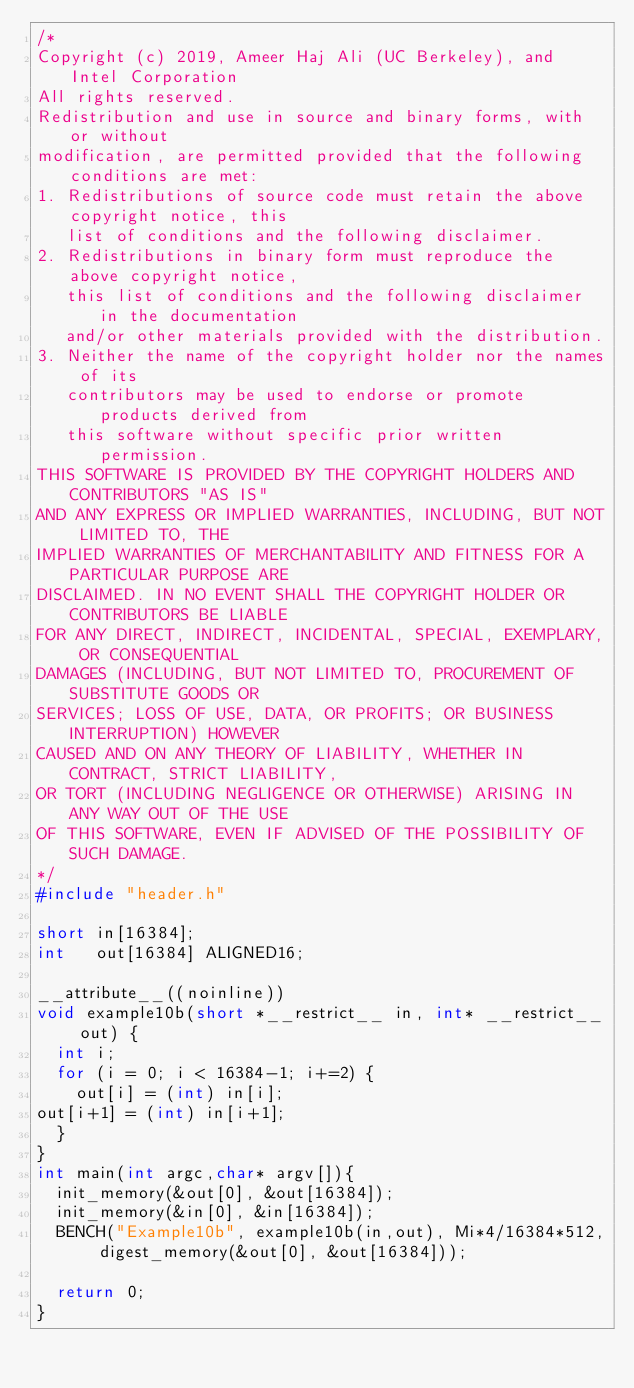Convert code to text. <code><loc_0><loc_0><loc_500><loc_500><_C_>/*
Copyright (c) 2019, Ameer Haj Ali (UC Berkeley), and Intel Corporation
All rights reserved.
Redistribution and use in source and binary forms, with or without
modification, are permitted provided that the following conditions are met:
1. Redistributions of source code must retain the above copyright notice, this
   list of conditions and the following disclaimer.
2. Redistributions in binary form must reproduce the above copyright notice,
   this list of conditions and the following disclaimer in the documentation
   and/or other materials provided with the distribution.
3. Neither the name of the copyright holder nor the names of its
   contributors may be used to endorse or promote products derived from
   this software without specific prior written permission.
THIS SOFTWARE IS PROVIDED BY THE COPYRIGHT HOLDERS AND CONTRIBUTORS "AS IS"
AND ANY EXPRESS OR IMPLIED WARRANTIES, INCLUDING, BUT NOT LIMITED TO, THE
IMPLIED WARRANTIES OF MERCHANTABILITY AND FITNESS FOR A PARTICULAR PURPOSE ARE
DISCLAIMED. IN NO EVENT SHALL THE COPYRIGHT HOLDER OR CONTRIBUTORS BE LIABLE
FOR ANY DIRECT, INDIRECT, INCIDENTAL, SPECIAL, EXEMPLARY, OR CONSEQUENTIAL
DAMAGES (INCLUDING, BUT NOT LIMITED TO, PROCUREMENT OF SUBSTITUTE GOODS OR
SERVICES; LOSS OF USE, DATA, OR PROFITS; OR BUSINESS INTERRUPTION) HOWEVER
CAUSED AND ON ANY THEORY OF LIABILITY, WHETHER IN CONTRACT, STRICT LIABILITY,
OR TORT (INCLUDING NEGLIGENCE OR OTHERWISE) ARISING IN ANY WAY OUT OF THE USE
OF THIS SOFTWARE, EVEN IF ADVISED OF THE POSSIBILITY OF SUCH DAMAGE.
*/
#include "header.h"

short in[16384];
int   out[16384] ALIGNED16;

__attribute__((noinline))
void example10b(short *__restrict__ in, int* __restrict__ out) {
  int i;
  for (i = 0; i < 16384-1; i+=2) {
    out[i] = (int) in[i];
out[i+1] = (int) in[i+1];
  }
}
int main(int argc,char* argv[]){
  init_memory(&out[0], &out[16384]);
  init_memory(&in[0], &in[16384]);
  BENCH("Example10b", example10b(in,out), Mi*4/16384*512, digest_memory(&out[0], &out[16384]));
 
  return 0;
}
</code> 